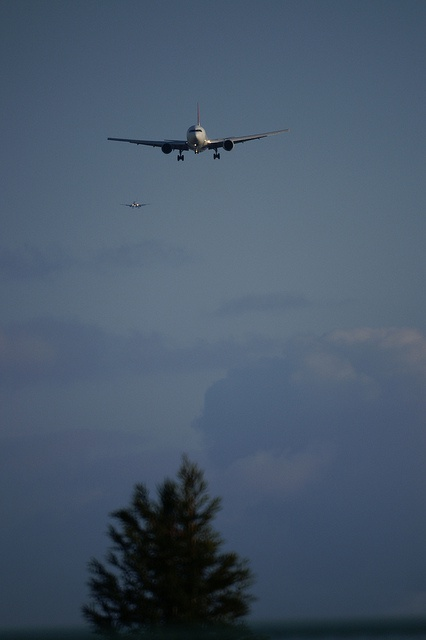Describe the objects in this image and their specific colors. I can see airplane in blue, black, gray, navy, and darkgray tones and airplane in blue, gray, and navy tones in this image. 